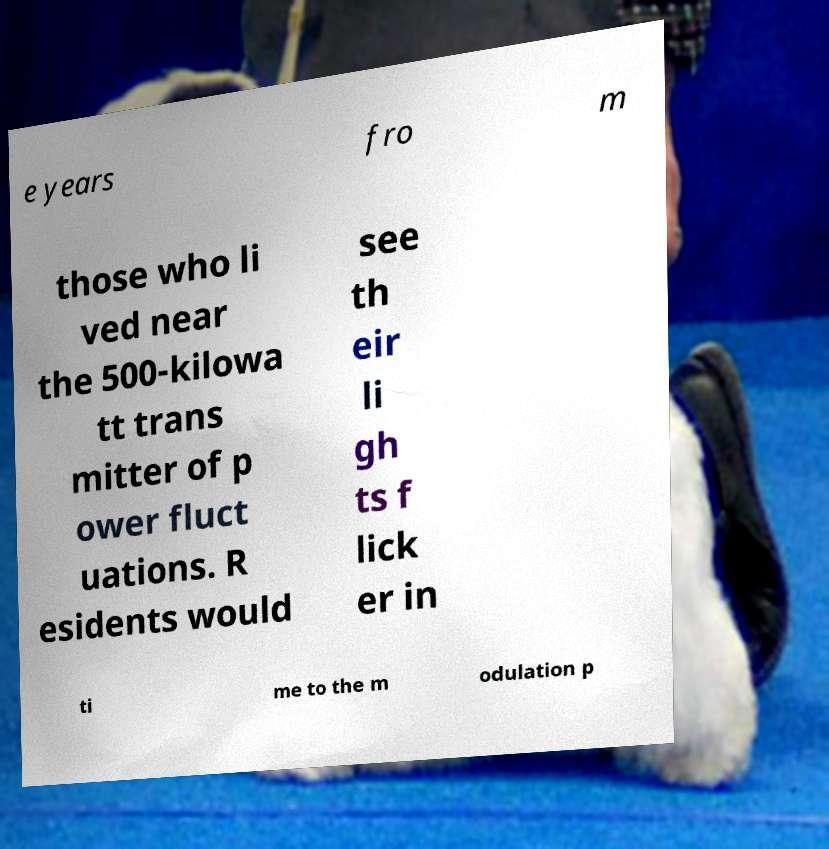I need the written content from this picture converted into text. Can you do that? e years fro m those who li ved near the 500-kilowa tt trans mitter of p ower fluct uations. R esidents would see th eir li gh ts f lick er in ti me to the m odulation p 